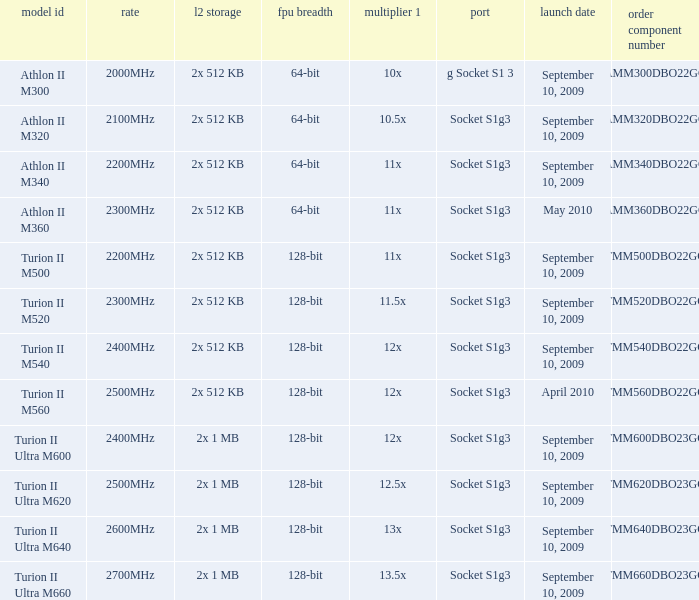What is the frequency of the tmm500dbo22gq order part number? 2200MHz. 